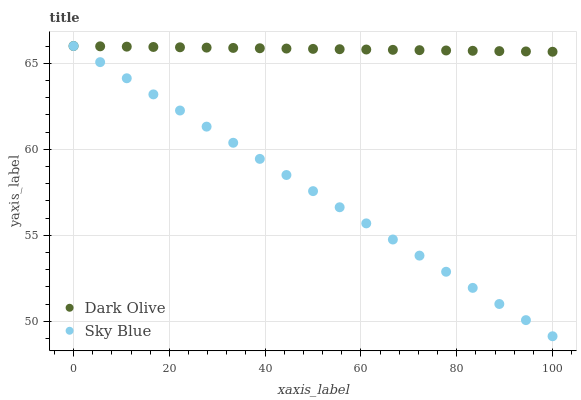Does Sky Blue have the minimum area under the curve?
Answer yes or no. Yes. Does Dark Olive have the maximum area under the curve?
Answer yes or no. Yes. Does Dark Olive have the minimum area under the curve?
Answer yes or no. No. Is Dark Olive the smoothest?
Answer yes or no. Yes. Is Sky Blue the roughest?
Answer yes or no. Yes. Is Dark Olive the roughest?
Answer yes or no. No. Does Sky Blue have the lowest value?
Answer yes or no. Yes. Does Dark Olive have the lowest value?
Answer yes or no. No. Does Dark Olive have the highest value?
Answer yes or no. Yes. Does Dark Olive intersect Sky Blue?
Answer yes or no. Yes. Is Dark Olive less than Sky Blue?
Answer yes or no. No. Is Dark Olive greater than Sky Blue?
Answer yes or no. No. 